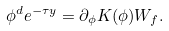Convert formula to latex. <formula><loc_0><loc_0><loc_500><loc_500>\phi ^ { d } e ^ { - \tau y } = \partial _ { \phi } K ( \phi ) W _ { f } .</formula> 